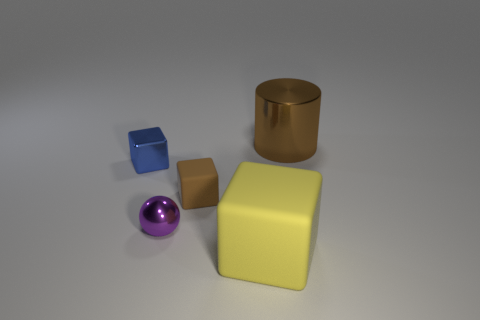Add 1 tiny purple blocks. How many objects exist? 6 Subtract all matte blocks. How many blocks are left? 1 Subtract all blocks. How many objects are left? 2 Subtract all purple blocks. Subtract all brown cylinders. How many blocks are left? 3 Subtract all big brown things. Subtract all brown things. How many objects are left? 2 Add 4 small purple spheres. How many small purple spheres are left? 5 Add 5 tiny balls. How many tiny balls exist? 6 Subtract 0 cyan blocks. How many objects are left? 5 